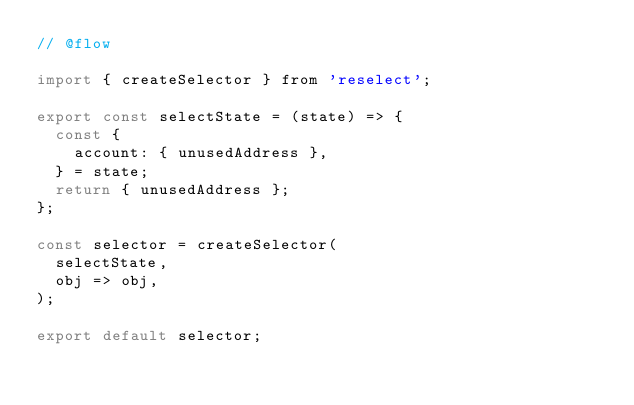Convert code to text. <code><loc_0><loc_0><loc_500><loc_500><_JavaScript_>// @flow

import { createSelector } from 'reselect';

export const selectState = (state) => {
  const {
    account: { unusedAddress },
  } = state;
  return { unusedAddress };
};

const selector = createSelector(
  selectState,
  obj => obj,
);

export default selector;
</code> 